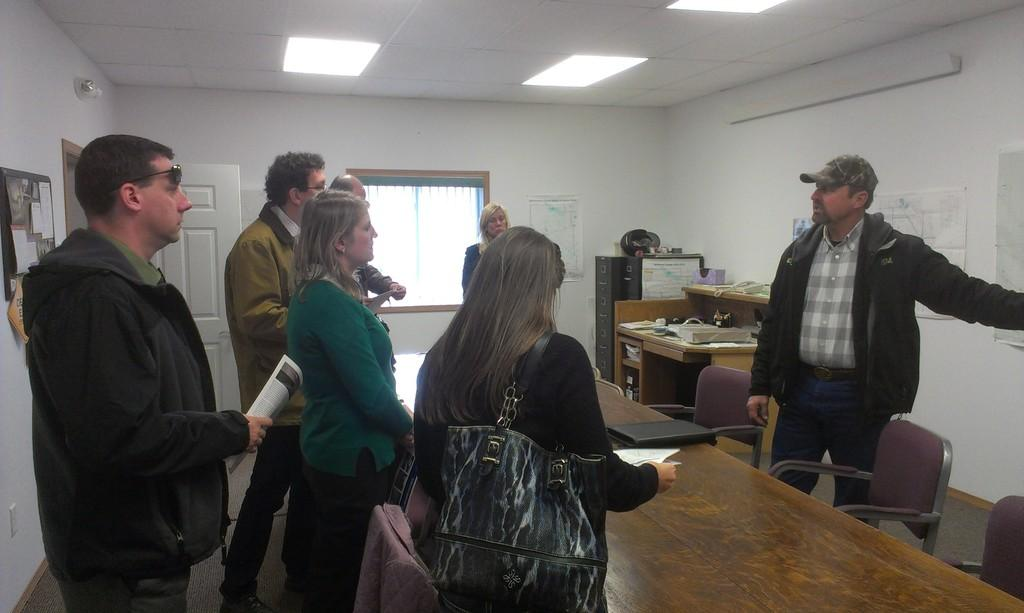How many people are in the room in the image? There is a group of people in the room in the image. What are the people in the room doing? The people are gathered around a table. Can you describe the person standing opposite the group? The person standing opposite the group is wearing a hat. What type of knowledge can be gained from observing the bikes in the image? There are no bikes present in the image, so no knowledge can be gained from observing them. 